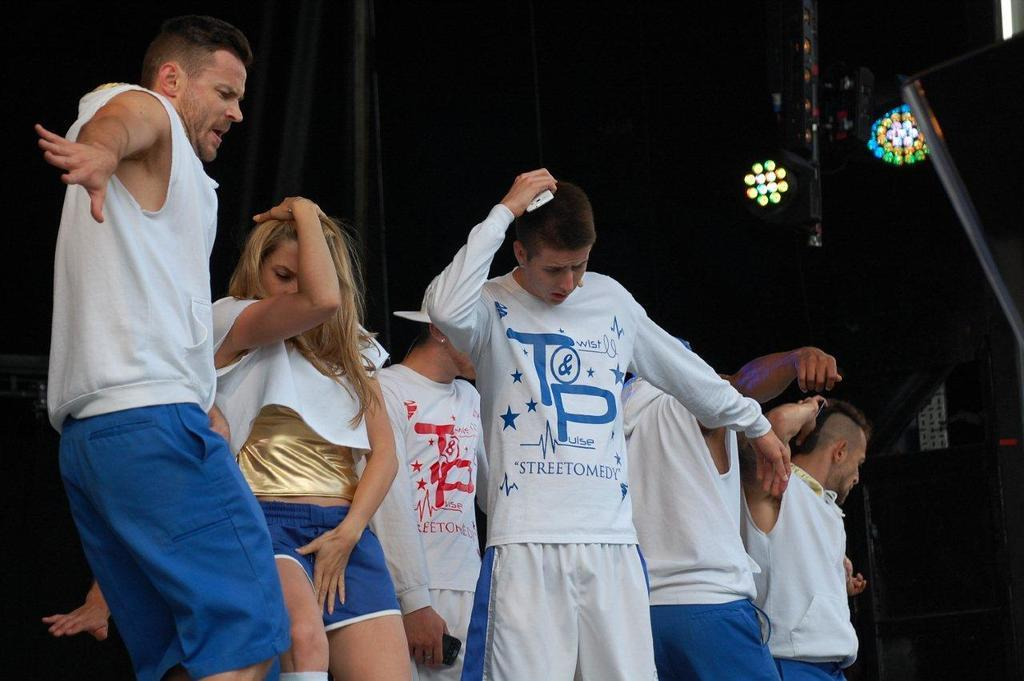What are the people in the image doing? The people in the image are dancing. What can be seen illuminating the dancers in the image? There is stage lighting visible in the image. How would you describe the overall lighting in the image? The background of the image is dark. How many chairs are visible in the image? There are no chairs present in the image. What type of lizards can be seen crawling on the dancers in the image? There are no lizards present in the image. 